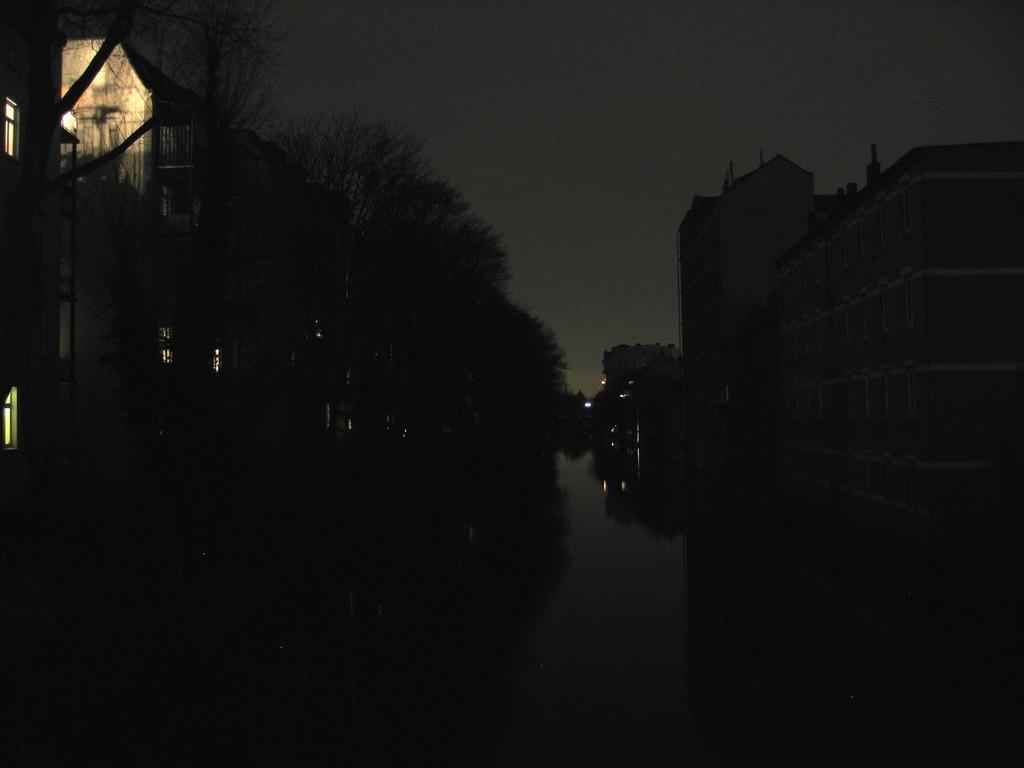What type of natural elements can be seen in the image? There are trees in the image. What type of man-made structures are present in the image? There are buildings in the image. What type of vertical structures can be seen in the image? There are poles in the image. What type of illumination is present in the image? There are lights in the image. What type of word can be seen on the trees in the image? There are no words present on the trees in the image. What type of smell can be detected from the buildings in the image? There is no information about smells in the image, as it only provides visual information. 